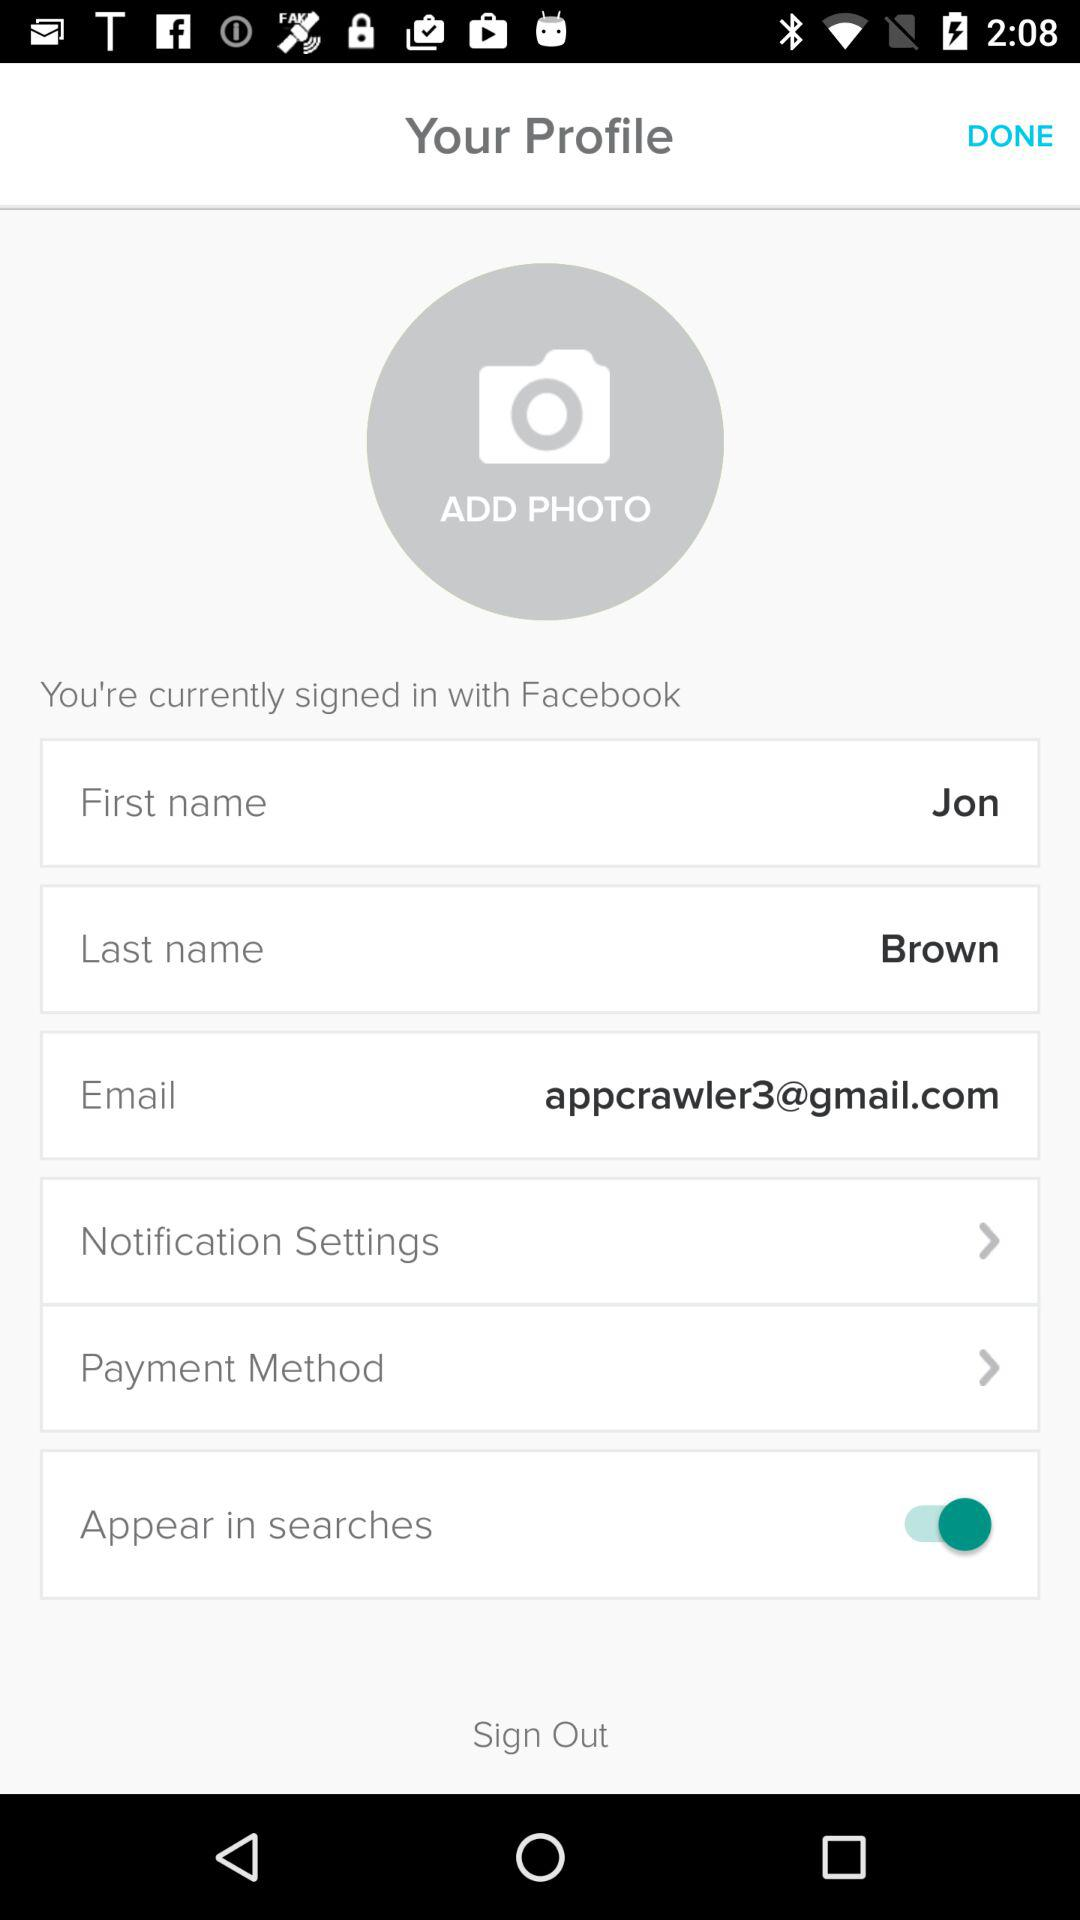By what app are we currently signed in? You are currently signed in with "Facebook". 